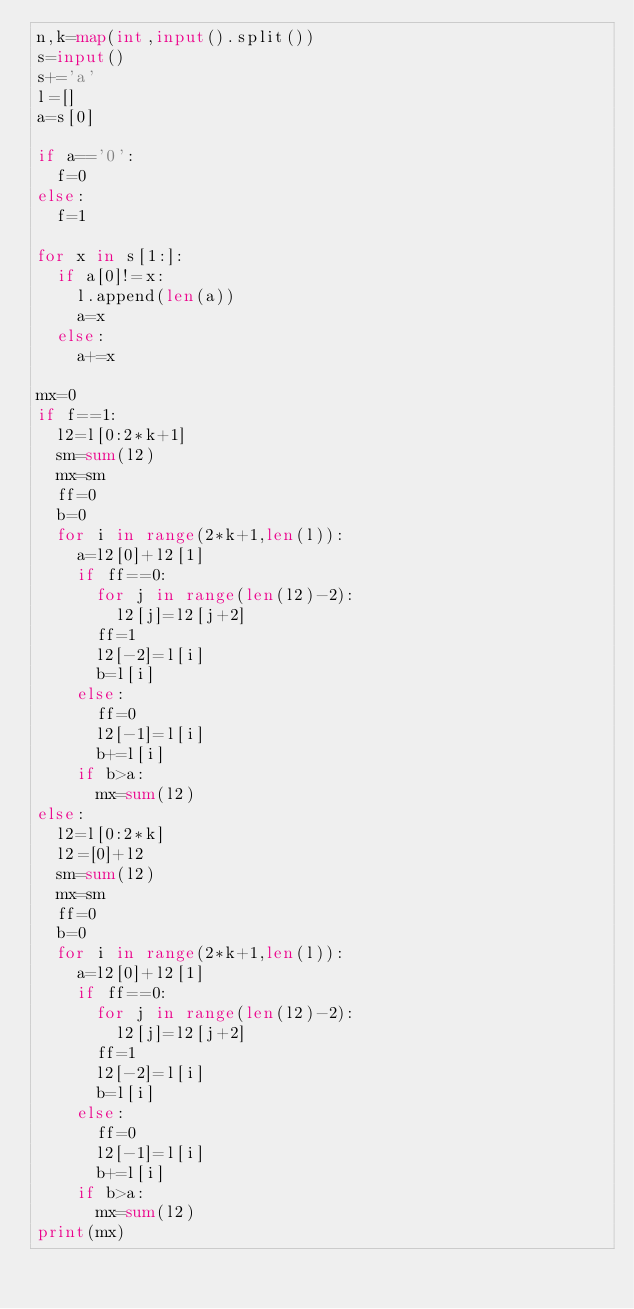<code> <loc_0><loc_0><loc_500><loc_500><_Python_>n,k=map(int,input().split())
s=input()
s+='a'
l=[]
a=s[0]

if a=='0':
  f=0
else:
  f=1

for x in s[1:]:
  if a[0]!=x:
    l.append(len(a))
    a=x
  else:
    a+=x

mx=0
if f==1:
  l2=l[0:2*k+1]
  sm=sum(l2)
  mx=sm
  ff=0
  b=0
  for i in range(2*k+1,len(l)):
    a=l2[0]+l2[1]
    if ff==0:
      for j in range(len(l2)-2):
        l2[j]=l2[j+2]
      ff=1
      l2[-2]=l[i]
      b=l[i]
    else:
      ff=0
      l2[-1]=l[i]
      b+=l[i]
    if b>a:
      mx=sum(l2)
else:
  l2=l[0:2*k]
  l2=[0]+l2
  sm=sum(l2)
  mx=sm
  ff=0
  b=0
  for i in range(2*k+1,len(l)):
    a=l2[0]+l2[1]
    if ff==0:
      for j in range(len(l2)-2):
        l2[j]=l2[j+2]
      ff=1
      l2[-2]=l[i]
      b=l[i]
    else:
      ff=0
      l2[-1]=l[i]
      b+=l[i]
    if b>a:
      mx=sum(l2)
print(mx)</code> 